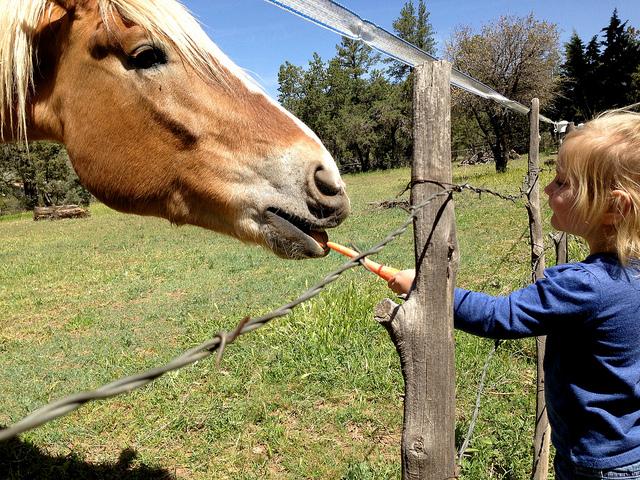Why is there a fence between the girl and the horse?
Quick response, please. Safety. Does the horses hair match the girls hair in color?
Answer briefly. Yes. Who has blonde hair?
Short answer required. Girl. 